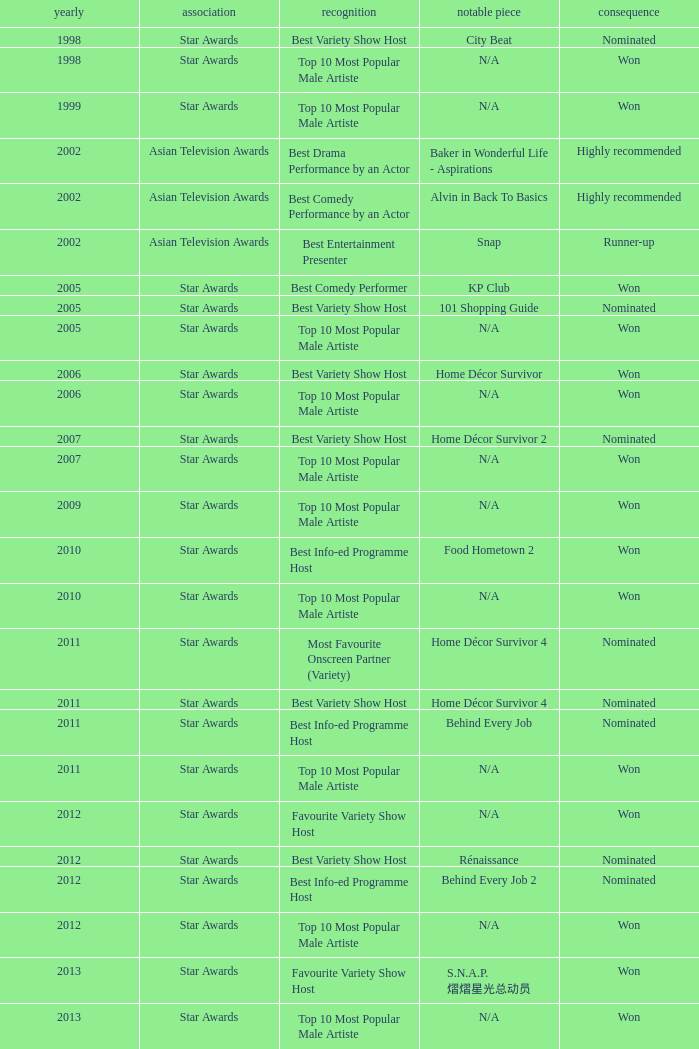What is the award for 1998 with Representative Work of city beat? Best Variety Show Host. Could you parse the entire table? {'header': ['yearly', 'association', 'recognition', 'notable piece', 'consequence'], 'rows': [['1998', 'Star Awards', 'Best Variety Show Host', 'City Beat', 'Nominated'], ['1998', 'Star Awards', 'Top 10 Most Popular Male Artiste', 'N/A', 'Won'], ['1999', 'Star Awards', 'Top 10 Most Popular Male Artiste', 'N/A', 'Won'], ['2002', 'Asian Television Awards', 'Best Drama Performance by an Actor', 'Baker in Wonderful Life - Aspirations', 'Highly recommended'], ['2002', 'Asian Television Awards', 'Best Comedy Performance by an Actor', 'Alvin in Back To Basics', 'Highly recommended'], ['2002', 'Asian Television Awards', 'Best Entertainment Presenter', 'Snap', 'Runner-up'], ['2005', 'Star Awards', 'Best Comedy Performer', 'KP Club', 'Won'], ['2005', 'Star Awards', 'Best Variety Show Host', '101 Shopping Guide', 'Nominated'], ['2005', 'Star Awards', 'Top 10 Most Popular Male Artiste', 'N/A', 'Won'], ['2006', 'Star Awards', 'Best Variety Show Host', 'Home Décor Survivor', 'Won'], ['2006', 'Star Awards', 'Top 10 Most Popular Male Artiste', 'N/A', 'Won'], ['2007', 'Star Awards', 'Best Variety Show Host', 'Home Décor Survivor 2', 'Nominated'], ['2007', 'Star Awards', 'Top 10 Most Popular Male Artiste', 'N/A', 'Won'], ['2009', 'Star Awards', 'Top 10 Most Popular Male Artiste', 'N/A', 'Won'], ['2010', 'Star Awards', 'Best Info-ed Programme Host', 'Food Hometown 2', 'Won'], ['2010', 'Star Awards', 'Top 10 Most Popular Male Artiste', 'N/A', 'Won'], ['2011', 'Star Awards', 'Most Favourite Onscreen Partner (Variety)', 'Home Décor Survivor 4', 'Nominated'], ['2011', 'Star Awards', 'Best Variety Show Host', 'Home Décor Survivor 4', 'Nominated'], ['2011', 'Star Awards', 'Best Info-ed Programme Host', 'Behind Every Job', 'Nominated'], ['2011', 'Star Awards', 'Top 10 Most Popular Male Artiste', 'N/A', 'Won'], ['2012', 'Star Awards', 'Favourite Variety Show Host', 'N/A', 'Won'], ['2012', 'Star Awards', 'Best Variety Show Host', 'Rénaissance', 'Nominated'], ['2012', 'Star Awards', 'Best Info-ed Programme Host', 'Behind Every Job 2', 'Nominated'], ['2012', 'Star Awards', 'Top 10 Most Popular Male Artiste', 'N/A', 'Won'], ['2013', 'Star Awards', 'Favourite Variety Show Host', 'S.N.A.P. 熠熠星光总动员', 'Won'], ['2013', 'Star Awards', 'Top 10 Most Popular Male Artiste', 'N/A', 'Won'], ['2013', 'Star Awards', 'Best Info-Ed Programme Host', 'Makan Unlimited', 'Nominated'], ['2013', 'Star Awards', 'Best Variety Show Host', 'Jobs Around The World', 'Nominated']]} 